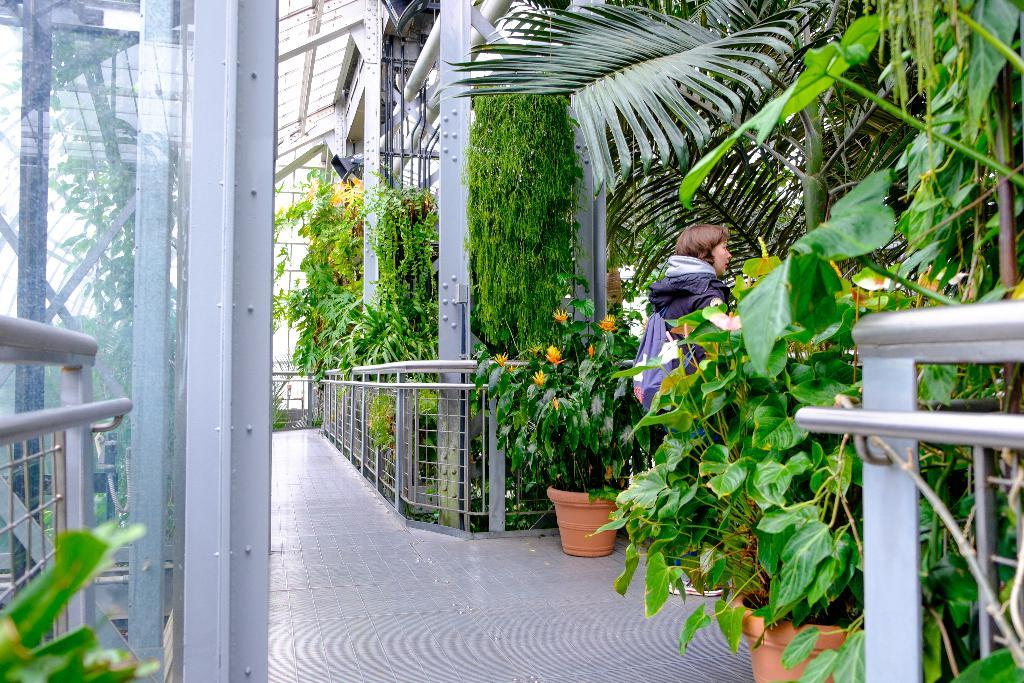What type of structure can be seen in the image? There is an iron grill in the image. What other elements are present in the image besides the iron grill? There are plants, trees, a house plant, and creepers in the image. Can you describe the floor in the image? The floor is visible in the image. Is there a person present in the image? Yes, there is a woman standing near the iron grill in the image. What type of stove can be seen in the image? There is no stove present in the image. What time of day is it in the image, given the presence of a morning dew on the cobwebs? There are no cobwebs present in the image, so it is not possible to determine the time of day based on that detail. 